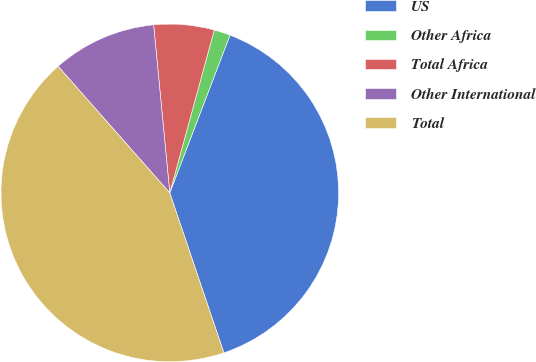<chart> <loc_0><loc_0><loc_500><loc_500><pie_chart><fcel>US<fcel>Other Africa<fcel>Total Africa<fcel>Other International<fcel>Total<nl><fcel>39.0%<fcel>1.56%<fcel>5.77%<fcel>9.98%<fcel>43.68%<nl></chart> 